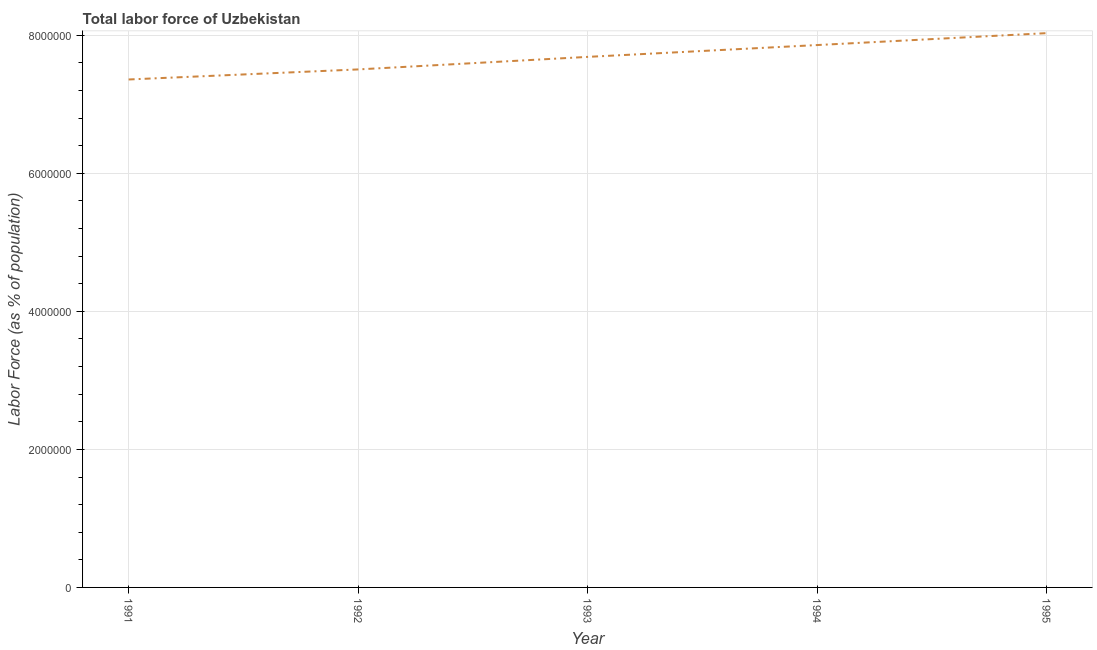What is the total labor force in 1992?
Keep it short and to the point. 7.51e+06. Across all years, what is the maximum total labor force?
Make the answer very short. 8.03e+06. Across all years, what is the minimum total labor force?
Give a very brief answer. 7.36e+06. What is the sum of the total labor force?
Provide a succinct answer. 3.84e+07. What is the difference between the total labor force in 1991 and 1992?
Your response must be concise. -1.46e+05. What is the average total labor force per year?
Your answer should be compact. 7.69e+06. What is the median total labor force?
Keep it short and to the point. 7.69e+06. In how many years, is the total labor force greater than 800000 %?
Your answer should be compact. 5. What is the ratio of the total labor force in 1991 to that in 1995?
Your response must be concise. 0.92. What is the difference between the highest and the second highest total labor force?
Give a very brief answer. 1.73e+05. What is the difference between the highest and the lowest total labor force?
Your answer should be very brief. 6.71e+05. Does the total labor force monotonically increase over the years?
Your answer should be very brief. Yes. What is the title of the graph?
Your answer should be very brief. Total labor force of Uzbekistan. What is the label or title of the X-axis?
Your answer should be very brief. Year. What is the label or title of the Y-axis?
Give a very brief answer. Labor Force (as % of population). What is the Labor Force (as % of population) in 1991?
Offer a very short reply. 7.36e+06. What is the Labor Force (as % of population) of 1992?
Make the answer very short. 7.51e+06. What is the Labor Force (as % of population) of 1993?
Offer a terse response. 7.69e+06. What is the Labor Force (as % of population) in 1994?
Your answer should be very brief. 7.86e+06. What is the Labor Force (as % of population) of 1995?
Make the answer very short. 8.03e+06. What is the difference between the Labor Force (as % of population) in 1991 and 1992?
Offer a terse response. -1.46e+05. What is the difference between the Labor Force (as % of population) in 1991 and 1993?
Give a very brief answer. -3.27e+05. What is the difference between the Labor Force (as % of population) in 1991 and 1994?
Provide a short and direct response. -4.99e+05. What is the difference between the Labor Force (as % of population) in 1991 and 1995?
Ensure brevity in your answer.  -6.71e+05. What is the difference between the Labor Force (as % of population) in 1992 and 1993?
Offer a terse response. -1.82e+05. What is the difference between the Labor Force (as % of population) in 1992 and 1994?
Ensure brevity in your answer.  -3.53e+05. What is the difference between the Labor Force (as % of population) in 1992 and 1995?
Keep it short and to the point. -5.26e+05. What is the difference between the Labor Force (as % of population) in 1993 and 1994?
Provide a succinct answer. -1.71e+05. What is the difference between the Labor Force (as % of population) in 1993 and 1995?
Offer a terse response. -3.44e+05. What is the difference between the Labor Force (as % of population) in 1994 and 1995?
Your answer should be very brief. -1.73e+05. What is the ratio of the Labor Force (as % of population) in 1991 to that in 1994?
Give a very brief answer. 0.94. What is the ratio of the Labor Force (as % of population) in 1991 to that in 1995?
Your answer should be compact. 0.92. What is the ratio of the Labor Force (as % of population) in 1992 to that in 1994?
Provide a succinct answer. 0.95. What is the ratio of the Labor Force (as % of population) in 1992 to that in 1995?
Give a very brief answer. 0.94. What is the ratio of the Labor Force (as % of population) in 1993 to that in 1994?
Offer a terse response. 0.98. What is the ratio of the Labor Force (as % of population) in 1994 to that in 1995?
Offer a very short reply. 0.98. 